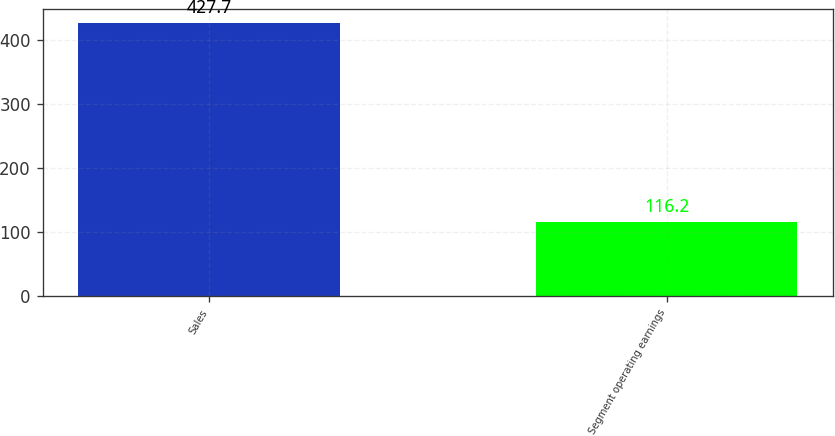<chart> <loc_0><loc_0><loc_500><loc_500><bar_chart><fcel>Sales<fcel>Segment operating earnings<nl><fcel>427.7<fcel>116.2<nl></chart> 